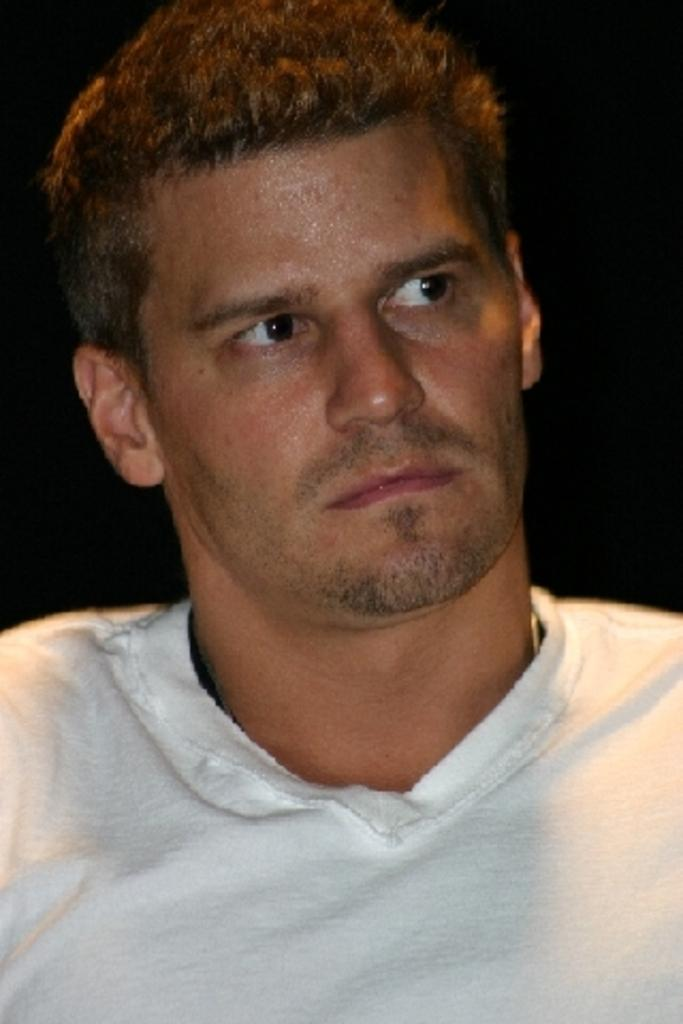Who is present in the image? There is a man in the image. What can be observed about the background of the image? The background of the image is dark. What type of button is the man wearing in the image? There is no button mentioned or visible in the image. How does the wren interact with the man in the image? There is no wren present in the image, so it cannot interact with the man. 